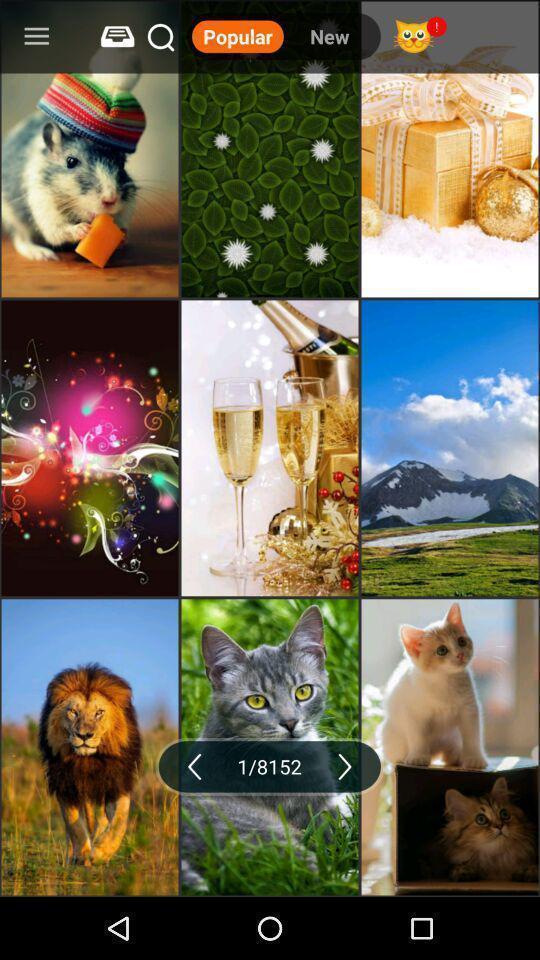Describe the visual elements of this screenshot. Screen showing the multiple images. 